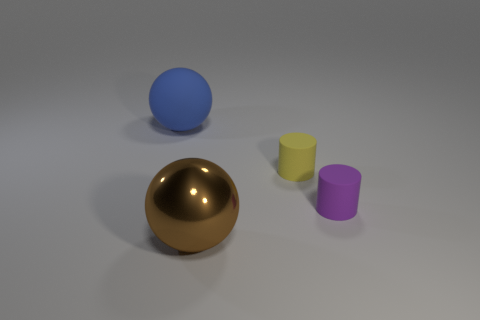Add 2 cyan blocks. How many objects exist? 6 Subtract all yellow cylinders. How many cylinders are left? 1 Subtract 2 cylinders. How many cylinders are left? 0 Add 3 brown metallic things. How many brown metallic things are left? 4 Add 1 tiny purple matte cylinders. How many tiny purple matte cylinders exist? 2 Subtract 1 yellow cylinders. How many objects are left? 3 Subtract all brown balls. Subtract all purple blocks. How many balls are left? 1 Subtract all matte cylinders. Subtract all small brown objects. How many objects are left? 2 